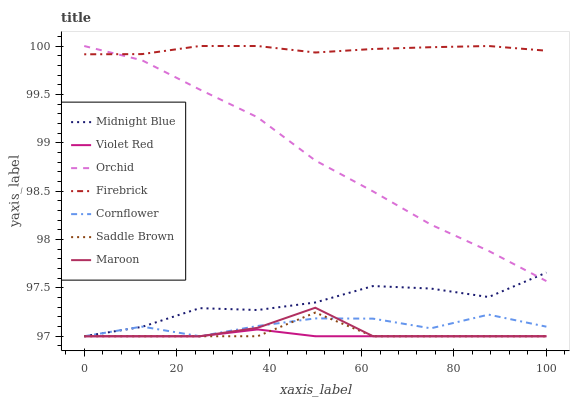Does Violet Red have the minimum area under the curve?
Answer yes or no. Yes. Does Firebrick have the maximum area under the curve?
Answer yes or no. Yes. Does Midnight Blue have the minimum area under the curve?
Answer yes or no. No. Does Midnight Blue have the maximum area under the curve?
Answer yes or no. No. Is Violet Red the smoothest?
Answer yes or no. Yes. Is Cornflower the roughest?
Answer yes or no. Yes. Is Midnight Blue the smoothest?
Answer yes or no. No. Is Midnight Blue the roughest?
Answer yes or no. No. Does Firebrick have the lowest value?
Answer yes or no. No. Does Midnight Blue have the highest value?
Answer yes or no. No. Is Midnight Blue less than Firebrick?
Answer yes or no. Yes. Is Firebrick greater than Cornflower?
Answer yes or no. Yes. Does Midnight Blue intersect Firebrick?
Answer yes or no. No. 